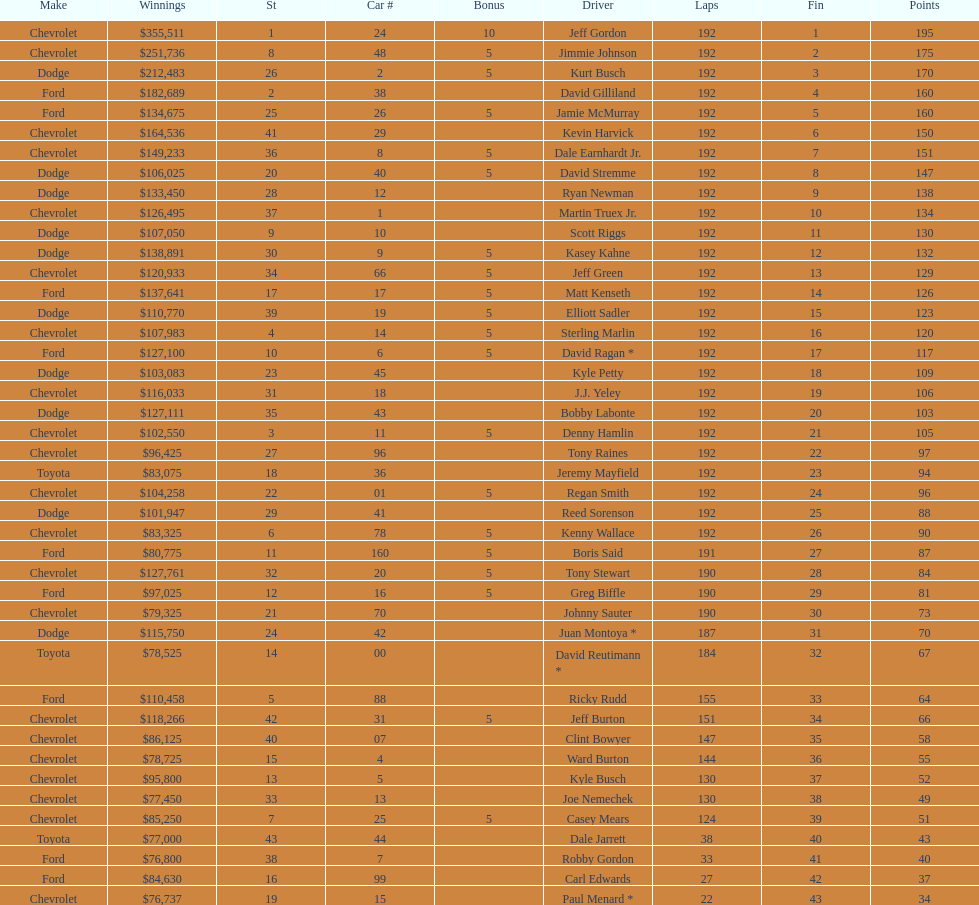How many drivers earned no bonus for this race? 23. Could you parse the entire table as a dict? {'header': ['Make', 'Winnings', 'St', 'Car #', 'Bonus', 'Driver', 'Laps', 'Fin', 'Points'], 'rows': [['Chevrolet', '$355,511', '1', '24', '10', 'Jeff Gordon', '192', '1', '195'], ['Chevrolet', '$251,736', '8', '48', '5', 'Jimmie Johnson', '192', '2', '175'], ['Dodge', '$212,483', '26', '2', '5', 'Kurt Busch', '192', '3', '170'], ['Ford', '$182,689', '2', '38', '', 'David Gilliland', '192', '4', '160'], ['Ford', '$134,675', '25', '26', '5', 'Jamie McMurray', '192', '5', '160'], ['Chevrolet', '$164,536', '41', '29', '', 'Kevin Harvick', '192', '6', '150'], ['Chevrolet', '$149,233', '36', '8', '5', 'Dale Earnhardt Jr.', '192', '7', '151'], ['Dodge', '$106,025', '20', '40', '5', 'David Stremme', '192', '8', '147'], ['Dodge', '$133,450', '28', '12', '', 'Ryan Newman', '192', '9', '138'], ['Chevrolet', '$126,495', '37', '1', '', 'Martin Truex Jr.', '192', '10', '134'], ['Dodge', '$107,050', '9', '10', '', 'Scott Riggs', '192', '11', '130'], ['Dodge', '$138,891', '30', '9', '5', 'Kasey Kahne', '192', '12', '132'], ['Chevrolet', '$120,933', '34', '66', '5', 'Jeff Green', '192', '13', '129'], ['Ford', '$137,641', '17', '17', '5', 'Matt Kenseth', '192', '14', '126'], ['Dodge', '$110,770', '39', '19', '5', 'Elliott Sadler', '192', '15', '123'], ['Chevrolet', '$107,983', '4', '14', '5', 'Sterling Marlin', '192', '16', '120'], ['Ford', '$127,100', '10', '6', '5', 'David Ragan *', '192', '17', '117'], ['Dodge', '$103,083', '23', '45', '', 'Kyle Petty', '192', '18', '109'], ['Chevrolet', '$116,033', '31', '18', '', 'J.J. Yeley', '192', '19', '106'], ['Dodge', '$127,111', '35', '43', '', 'Bobby Labonte', '192', '20', '103'], ['Chevrolet', '$102,550', '3', '11', '5', 'Denny Hamlin', '192', '21', '105'], ['Chevrolet', '$96,425', '27', '96', '', 'Tony Raines', '192', '22', '97'], ['Toyota', '$83,075', '18', '36', '', 'Jeremy Mayfield', '192', '23', '94'], ['Chevrolet', '$104,258', '22', '01', '5', 'Regan Smith', '192', '24', '96'], ['Dodge', '$101,947', '29', '41', '', 'Reed Sorenson', '192', '25', '88'], ['Chevrolet', '$83,325', '6', '78', '5', 'Kenny Wallace', '192', '26', '90'], ['Ford', '$80,775', '11', '160', '5', 'Boris Said', '191', '27', '87'], ['Chevrolet', '$127,761', '32', '20', '5', 'Tony Stewart', '190', '28', '84'], ['Ford', '$97,025', '12', '16', '5', 'Greg Biffle', '190', '29', '81'], ['Chevrolet', '$79,325', '21', '70', '', 'Johnny Sauter', '190', '30', '73'], ['Dodge', '$115,750', '24', '42', '', 'Juan Montoya *', '187', '31', '70'], ['Toyota', '$78,525', '14', '00', '', 'David Reutimann *', '184', '32', '67'], ['Ford', '$110,458', '5', '88', '', 'Ricky Rudd', '155', '33', '64'], ['Chevrolet', '$118,266', '42', '31', '5', 'Jeff Burton', '151', '34', '66'], ['Chevrolet', '$86,125', '40', '07', '', 'Clint Bowyer', '147', '35', '58'], ['Chevrolet', '$78,725', '15', '4', '', 'Ward Burton', '144', '36', '55'], ['Chevrolet', '$95,800', '13', '5', '', 'Kyle Busch', '130', '37', '52'], ['Chevrolet', '$77,450', '33', '13', '', 'Joe Nemechek', '130', '38', '49'], ['Chevrolet', '$85,250', '7', '25', '5', 'Casey Mears', '124', '39', '51'], ['Toyota', '$77,000', '43', '44', '', 'Dale Jarrett', '38', '40', '43'], ['Ford', '$76,800', '38', '7', '', 'Robby Gordon', '33', '41', '40'], ['Ford', '$84,630', '16', '99', '', 'Carl Edwards', '27', '42', '37'], ['Chevrolet', '$76,737', '19', '15', '', 'Paul Menard *', '22', '43', '34']]} 